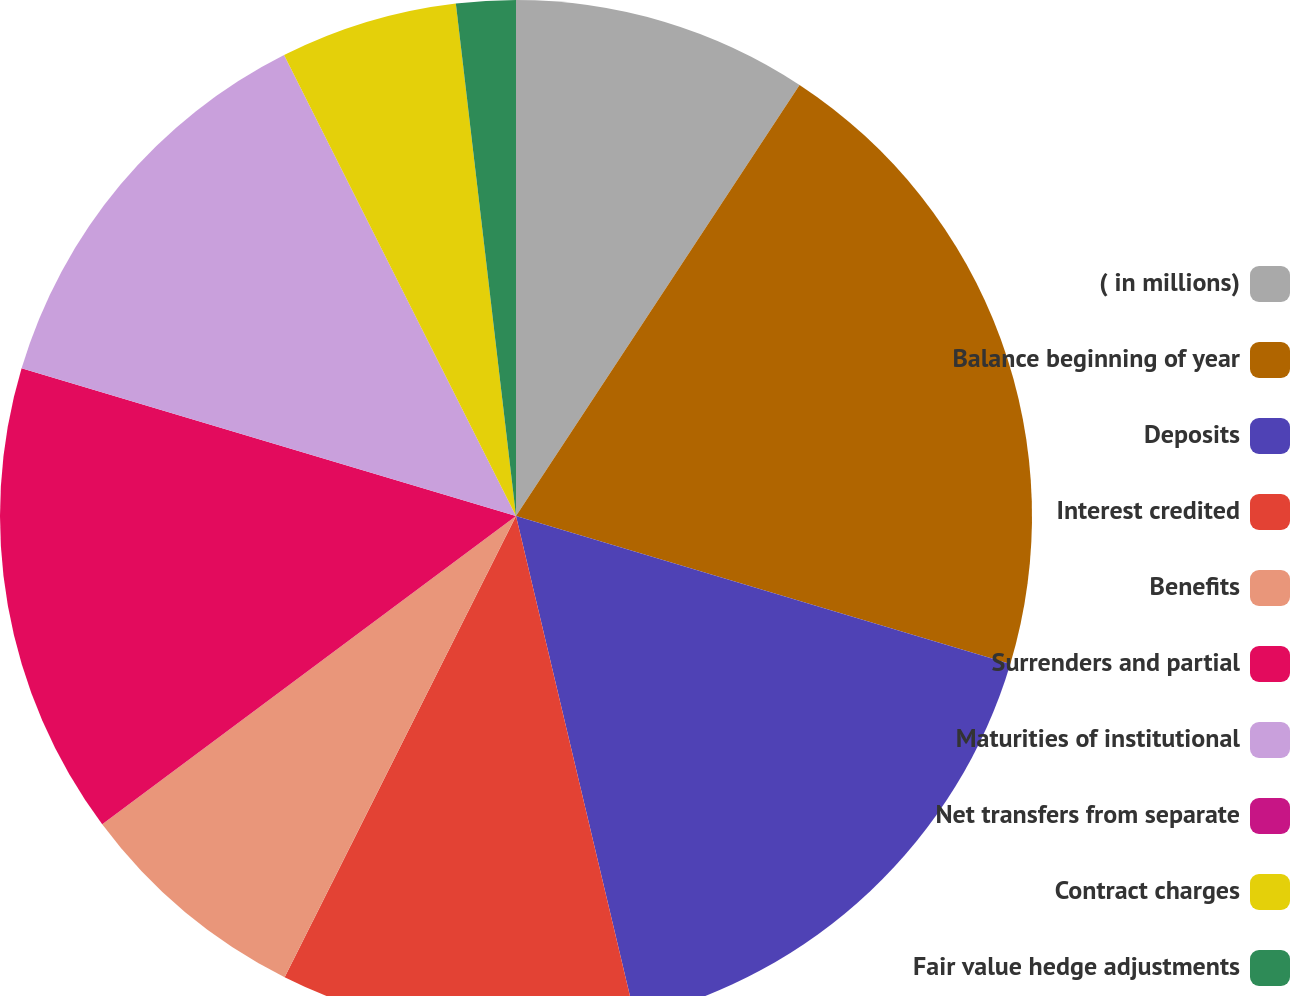Convert chart. <chart><loc_0><loc_0><loc_500><loc_500><pie_chart><fcel>( in millions)<fcel>Balance beginning of year<fcel>Deposits<fcel>Interest credited<fcel>Benefits<fcel>Surrenders and partial<fcel>Maturities of institutional<fcel>Net transfers from separate<fcel>Contract charges<fcel>Fair value hedge adjustments<nl><fcel>9.26%<fcel>20.37%<fcel>16.66%<fcel>11.11%<fcel>7.41%<fcel>14.81%<fcel>12.96%<fcel>0.0%<fcel>5.56%<fcel>1.86%<nl></chart> 